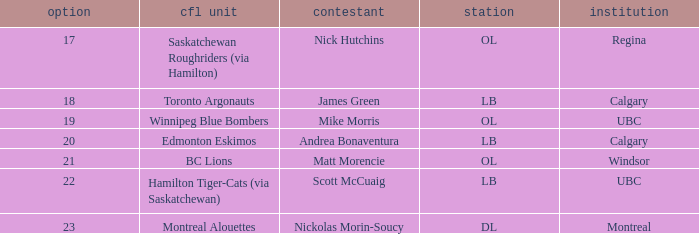What number picks were the players who went to Calgary?  18, 20. 